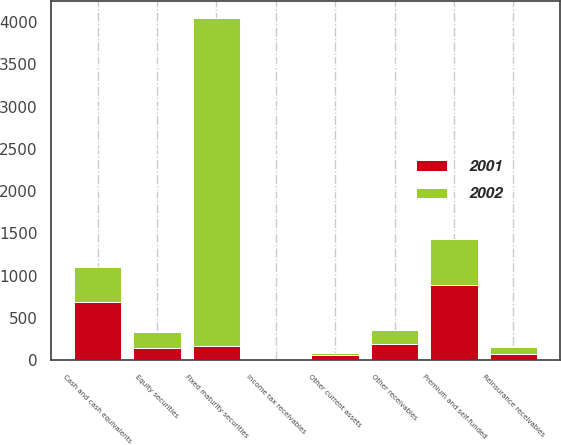Convert chart to OTSL. <chart><loc_0><loc_0><loc_500><loc_500><stacked_bar_chart><ecel><fcel>Fixed maturity securities<fcel>Equity securities<fcel>Cash and cash equivalents<fcel>Premium and self-funded<fcel>Reinsurance receivables<fcel>Other receivables<fcel>Income tax receivables<fcel>Other current assets<nl><fcel>2001<fcel>169.1<fcel>150.7<fcel>694.9<fcel>892.7<fcel>76.5<fcel>192.3<fcel>11.7<fcel>60.3<nl><fcel>2002<fcel>3882.7<fcel>189.1<fcel>406.4<fcel>544.7<fcel>76.7<fcel>169.1<fcel>0.4<fcel>30.8<nl></chart> 